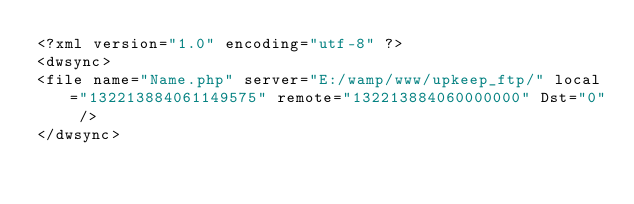<code> <loc_0><loc_0><loc_500><loc_500><_XML_><?xml version="1.0" encoding="utf-8" ?>
<dwsync>
<file name="Name.php" server="E:/wamp/www/upkeep_ftp/" local="132213884061149575" remote="132213884060000000" Dst="0" />
</dwsync></code> 